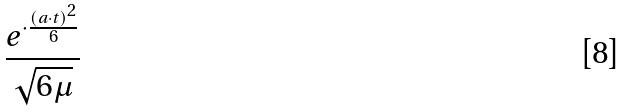Convert formula to latex. <formula><loc_0><loc_0><loc_500><loc_500>\frac { e ^ { \cdot \frac { ( a \cdot t ) ^ { 2 } } { 6 } } } { \sqrt { 6 \mu } }</formula> 